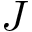Convert formula to latex. <formula><loc_0><loc_0><loc_500><loc_500>J</formula> 